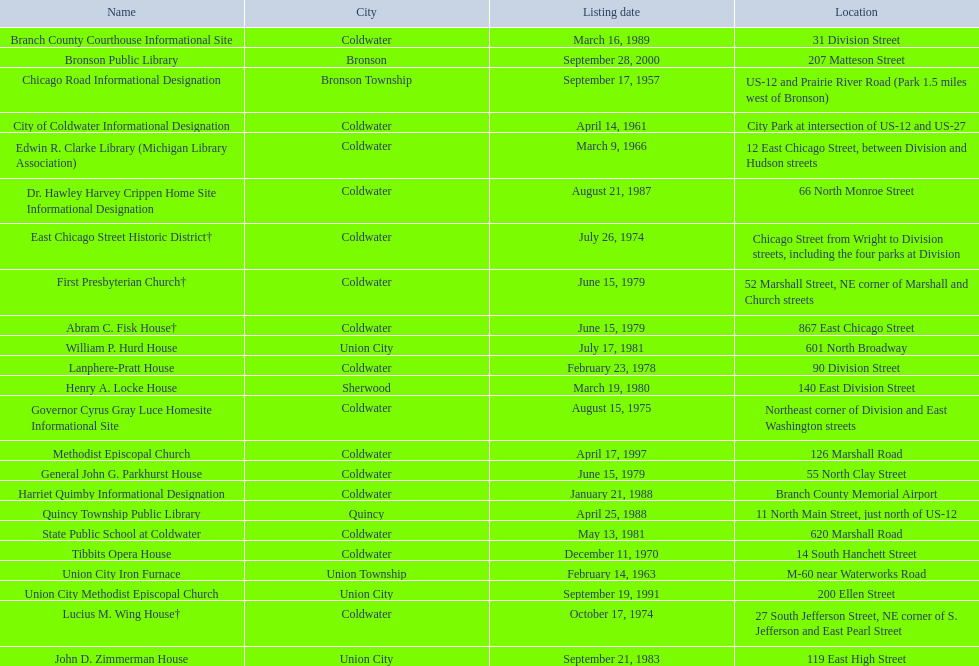Which site was listed earlier, the state public school or the edwin r. clarke library? Edwin R. Clarke Library. 